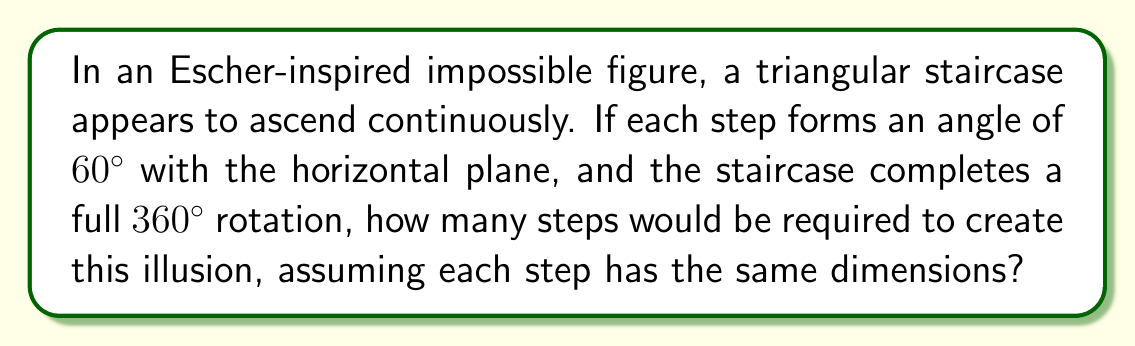Help me with this question. Let's approach this step-by-step:

1) In a normal Euclidean space, a staircase that rotates $360^\circ$ would form a closed loop. However, in this impossible figure, we're dealing with a non-Euclidean geometry that creates the illusion of continuous ascent.

2) Each step forms a $60^\circ$ angle with the horizontal plane. This means that each step contributes $60^\circ$ to the overall rotation.

3) To calculate the number of steps, we need to divide the total rotation by the angle of each step:

   $$\text{Number of steps} = \frac{\text{Total rotation}}{\text{Angle per step}}$$

4) Substituting the values:

   $$\text{Number of steps} = \frac{360^\circ}{60^\circ} = 6$$

5) This result creates the paradox: After 6 steps, we've completed a full rotation, yet in the impossible figure, we appear to keep ascending.

6) In artistic terms, this could be represented by drawing 6 steps that seem to connect in an impossible loop, each at a $60^\circ$ angle to the previous one.

[asy]
unitsize(1cm);
for(int i=0; i<6; ++i) {
  draw((0,0)--(1,0)--(1,1)--(0,1)--cycle);
  draw((1,0)--(1,1));
  label("$60^\circ$", (0.5,0.2));
  rotate(60);
}
[/asy]

This diagram illustrates how the 6 steps would be arranged to create the illusion of an impossible, continuously ascending staircase.
Answer: 6 steps 